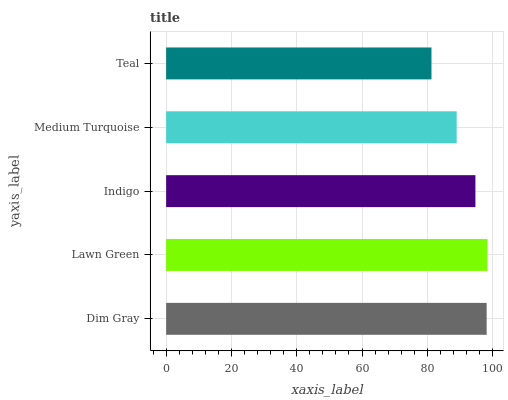Is Teal the minimum?
Answer yes or no. Yes. Is Lawn Green the maximum?
Answer yes or no. Yes. Is Indigo the minimum?
Answer yes or no. No. Is Indigo the maximum?
Answer yes or no. No. Is Lawn Green greater than Indigo?
Answer yes or no. Yes. Is Indigo less than Lawn Green?
Answer yes or no. Yes. Is Indigo greater than Lawn Green?
Answer yes or no. No. Is Lawn Green less than Indigo?
Answer yes or no. No. Is Indigo the high median?
Answer yes or no. Yes. Is Indigo the low median?
Answer yes or no. Yes. Is Lawn Green the high median?
Answer yes or no. No. Is Medium Turquoise the low median?
Answer yes or no. No. 